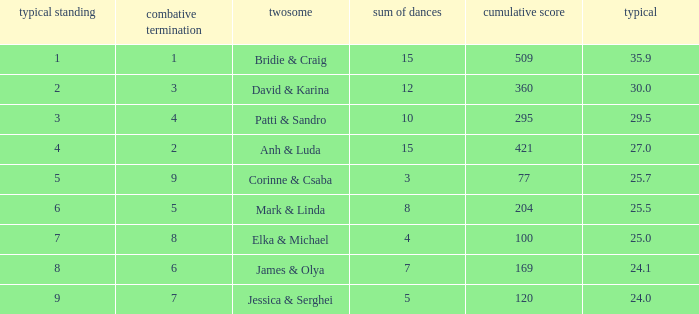What is the average for the couple anh & luda? 27.0. 